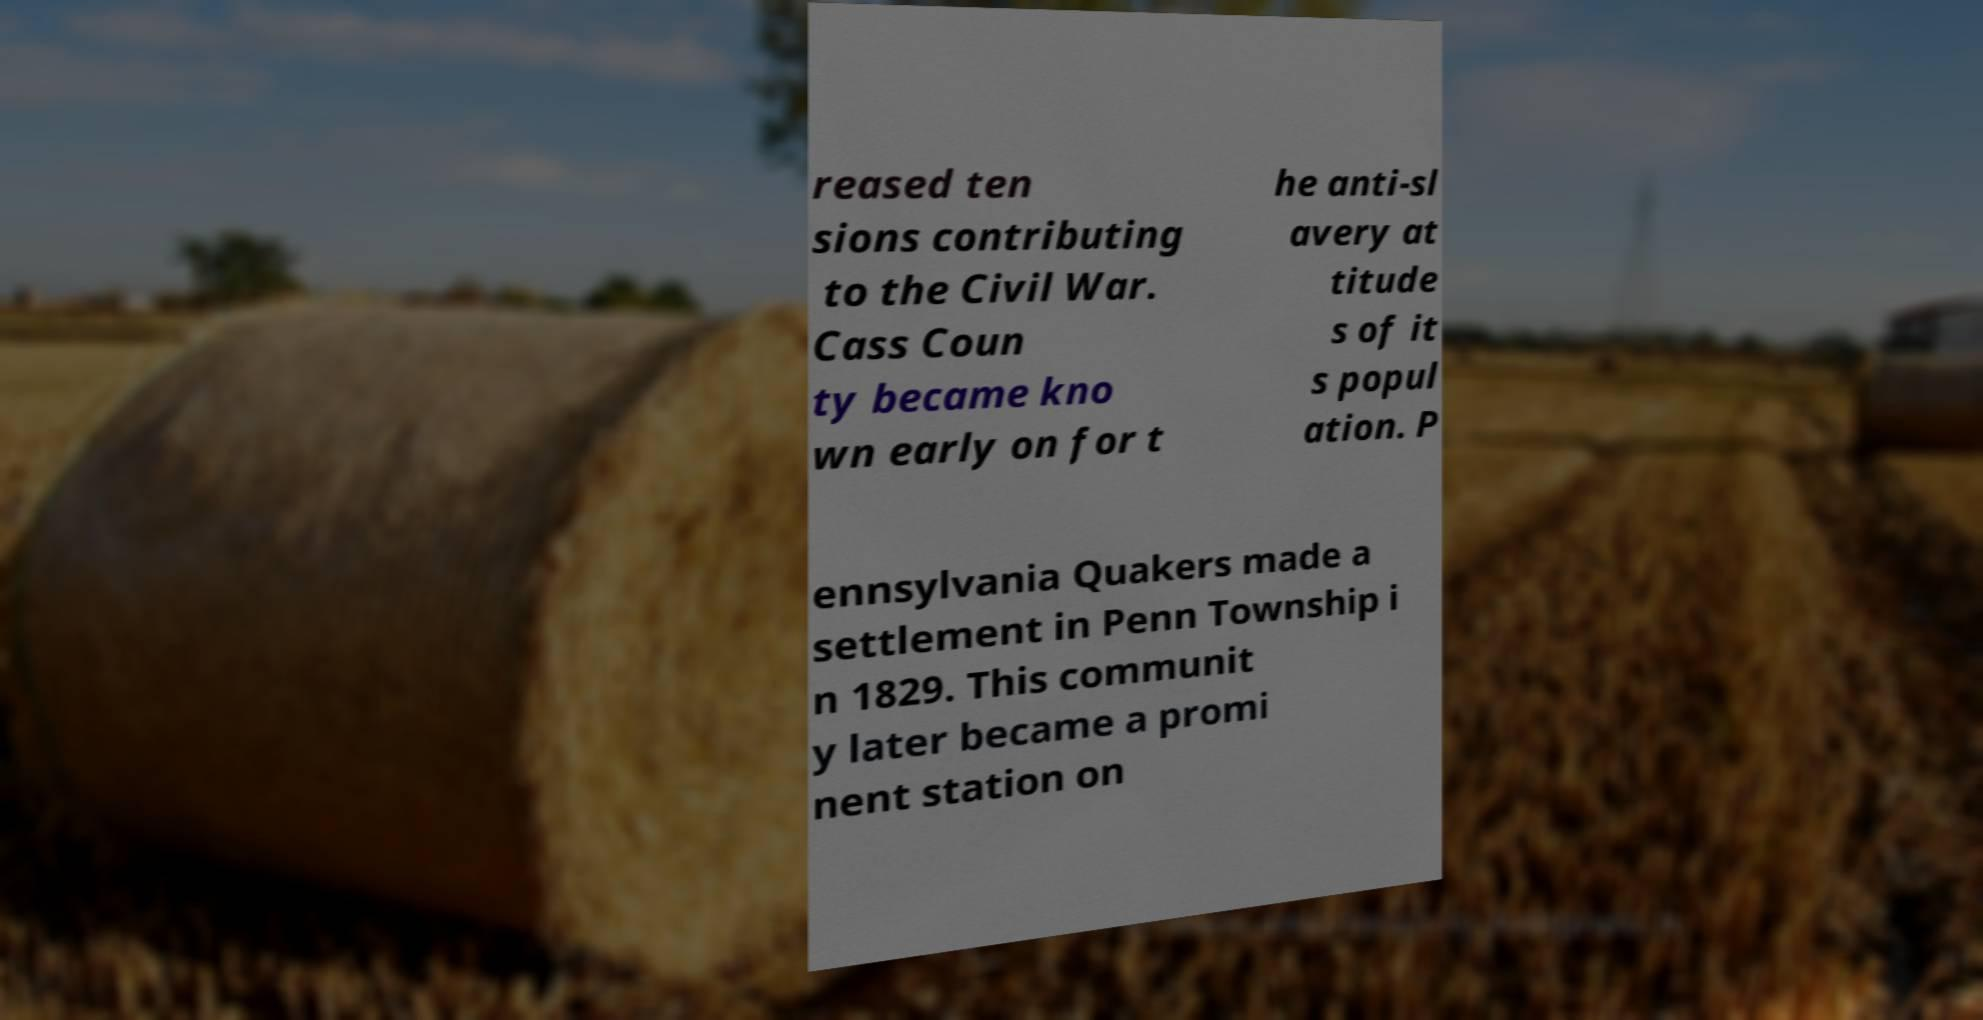Could you extract and type out the text from this image? reased ten sions contributing to the Civil War. Cass Coun ty became kno wn early on for t he anti-sl avery at titude s of it s popul ation. P ennsylvania Quakers made a settlement in Penn Township i n 1829. This communit y later became a promi nent station on 